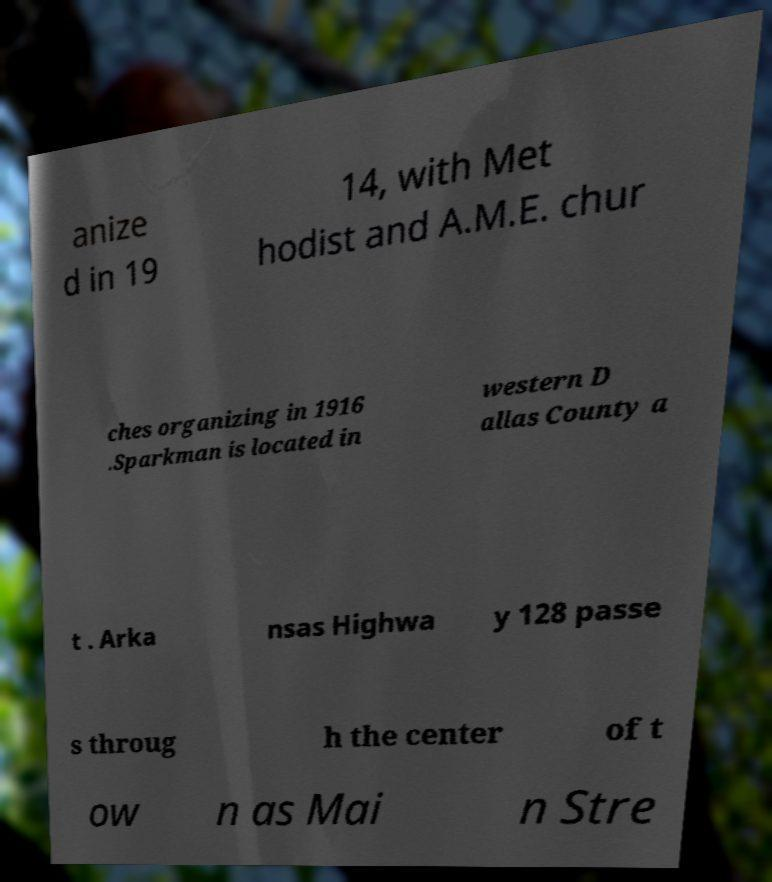Can you read and provide the text displayed in the image?This photo seems to have some interesting text. Can you extract and type it out for me? anize d in 19 14, with Met hodist and A.M.E. chur ches organizing in 1916 .Sparkman is located in western D allas County a t . Arka nsas Highwa y 128 passe s throug h the center of t ow n as Mai n Stre 